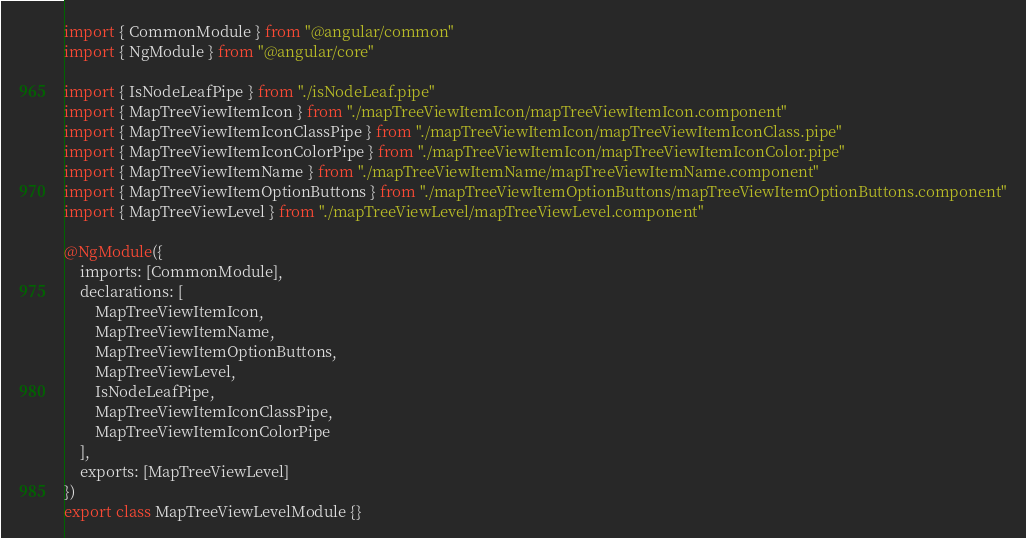Convert code to text. <code><loc_0><loc_0><loc_500><loc_500><_TypeScript_>import { CommonModule } from "@angular/common"
import { NgModule } from "@angular/core"

import { IsNodeLeafPipe } from "./isNodeLeaf.pipe"
import { MapTreeViewItemIcon } from "./mapTreeViewItemIcon/mapTreeViewItemIcon.component"
import { MapTreeViewItemIconClassPipe } from "./mapTreeViewItemIcon/mapTreeViewItemIconClass.pipe"
import { MapTreeViewItemIconColorPipe } from "./mapTreeViewItemIcon/mapTreeViewItemIconColor.pipe"
import { MapTreeViewItemName } from "./mapTreeViewItemName/mapTreeViewItemName.component"
import { MapTreeViewItemOptionButtons } from "./mapTreeViewItemOptionButtons/mapTreeViewItemOptionButtons.component"
import { MapTreeViewLevel } from "./mapTreeViewLevel/mapTreeViewLevel.component"

@NgModule({
	imports: [CommonModule],
	declarations: [
		MapTreeViewItemIcon,
		MapTreeViewItemName,
		MapTreeViewItemOptionButtons,
		MapTreeViewLevel,
		IsNodeLeafPipe,
		MapTreeViewItemIconClassPipe,
		MapTreeViewItemIconColorPipe
	],
	exports: [MapTreeViewLevel]
})
export class MapTreeViewLevelModule {}
</code> 